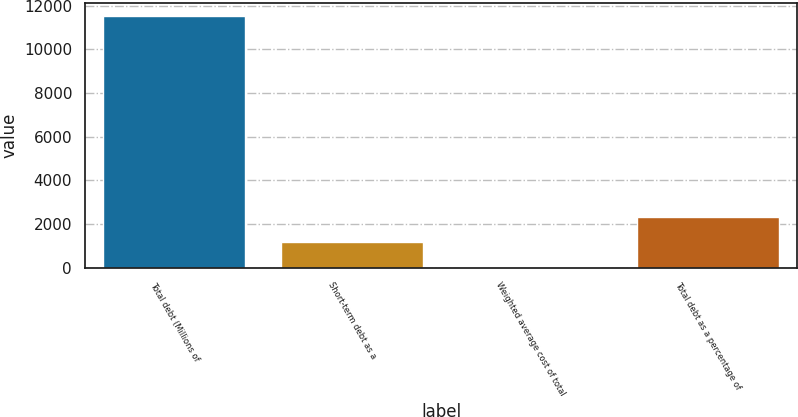Convert chart to OTSL. <chart><loc_0><loc_0><loc_500><loc_500><bar_chart><fcel>Total debt (Millions of<fcel>Short-term debt as a<fcel>Weighted average cost of total<fcel>Total debt as a percentage of<nl><fcel>11551<fcel>1158.34<fcel>3.6<fcel>2313.08<nl></chart> 